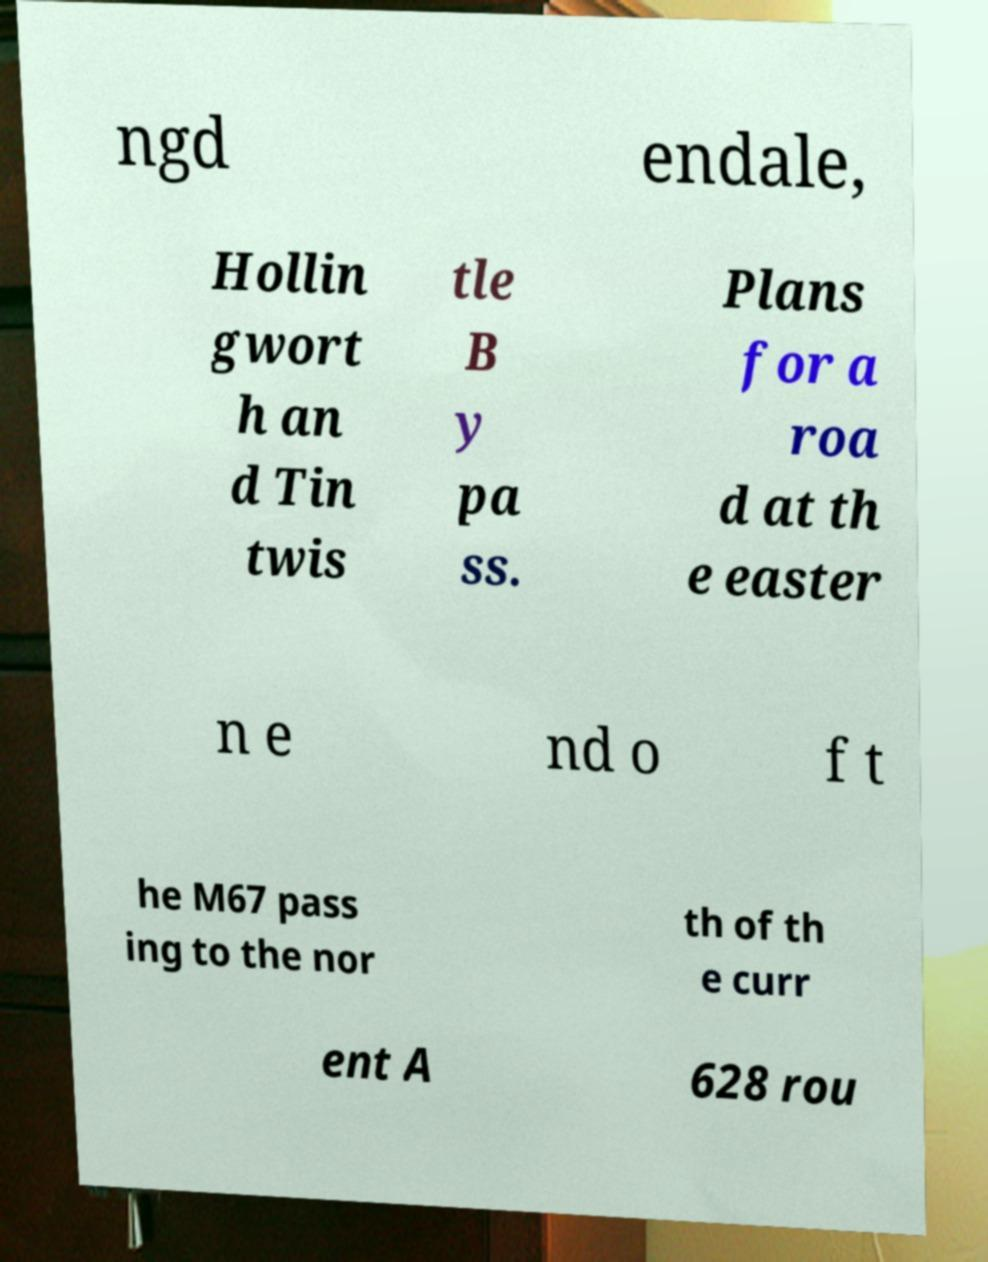Could you assist in decoding the text presented in this image and type it out clearly? ngd endale, Hollin gwort h an d Tin twis tle B y pa ss. Plans for a roa d at th e easter n e nd o f t he M67 pass ing to the nor th of th e curr ent A 628 rou 